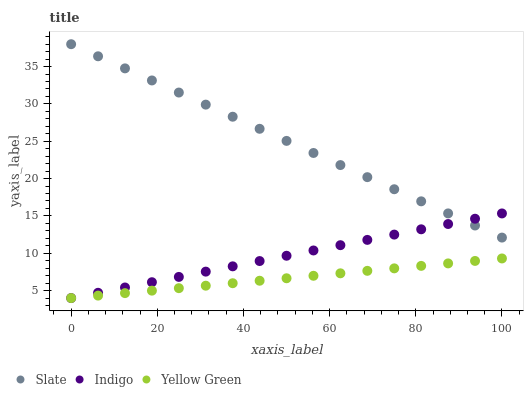Does Yellow Green have the minimum area under the curve?
Answer yes or no. Yes. Does Slate have the maximum area under the curve?
Answer yes or no. Yes. Does Indigo have the minimum area under the curve?
Answer yes or no. No. Does Indigo have the maximum area under the curve?
Answer yes or no. No. Is Slate the smoothest?
Answer yes or no. Yes. Is Indigo the roughest?
Answer yes or no. Yes. Is Yellow Green the smoothest?
Answer yes or no. No. Is Yellow Green the roughest?
Answer yes or no. No. Does Indigo have the lowest value?
Answer yes or no. Yes. Does Slate have the highest value?
Answer yes or no. Yes. Does Indigo have the highest value?
Answer yes or no. No. Is Yellow Green less than Slate?
Answer yes or no. Yes. Is Slate greater than Yellow Green?
Answer yes or no. Yes. Does Slate intersect Indigo?
Answer yes or no. Yes. Is Slate less than Indigo?
Answer yes or no. No. Is Slate greater than Indigo?
Answer yes or no. No. Does Yellow Green intersect Slate?
Answer yes or no. No. 